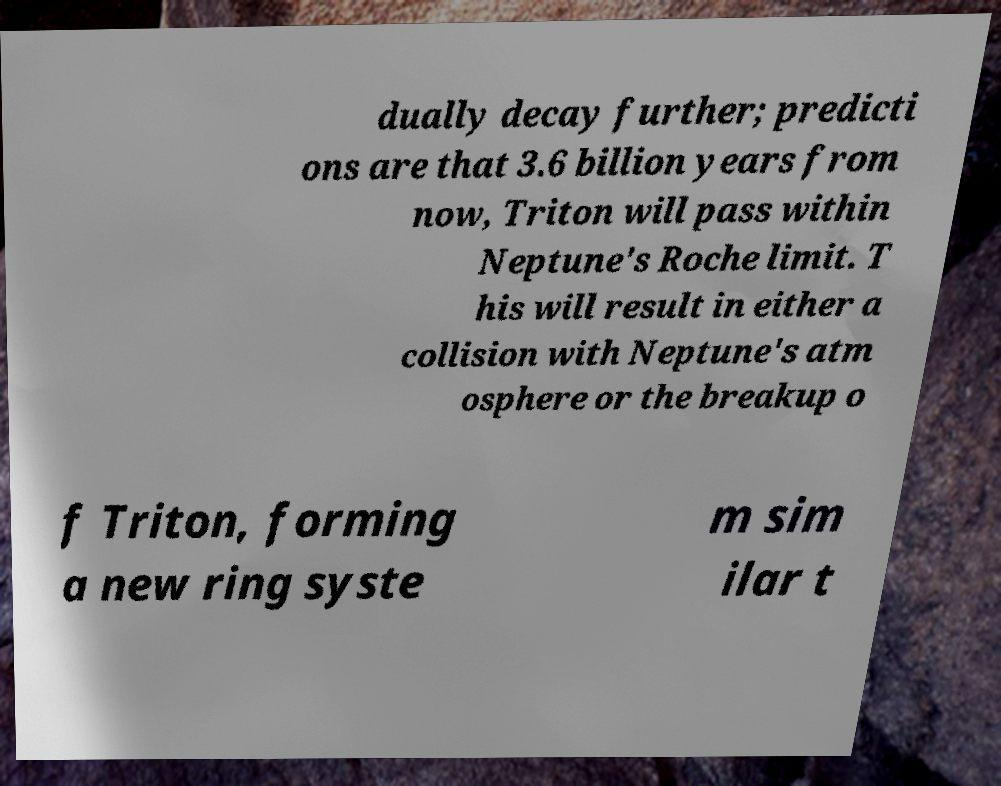Please identify and transcribe the text found in this image. dually decay further; predicti ons are that 3.6 billion years from now, Triton will pass within Neptune's Roche limit. T his will result in either a collision with Neptune's atm osphere or the breakup o f Triton, forming a new ring syste m sim ilar t 